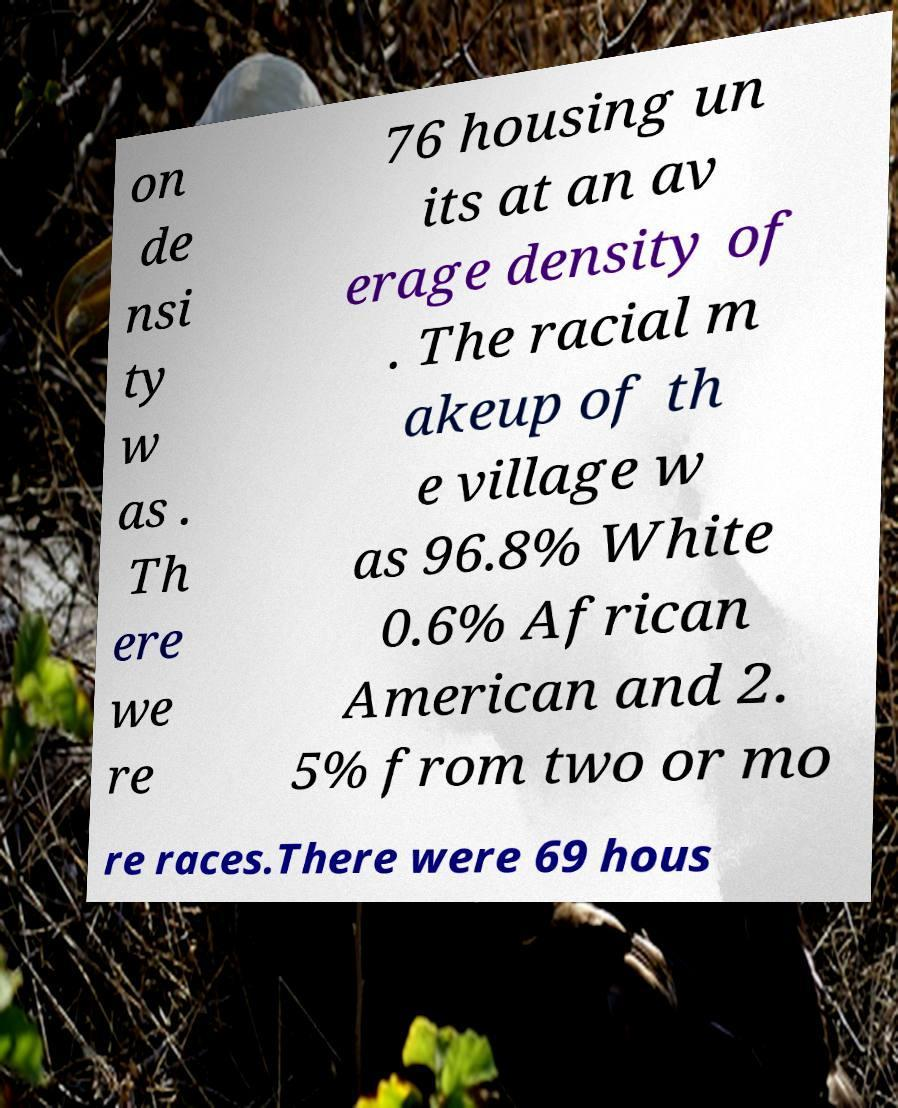I need the written content from this picture converted into text. Can you do that? on de nsi ty w as . Th ere we re 76 housing un its at an av erage density of . The racial m akeup of th e village w as 96.8% White 0.6% African American and 2. 5% from two or mo re races.There were 69 hous 